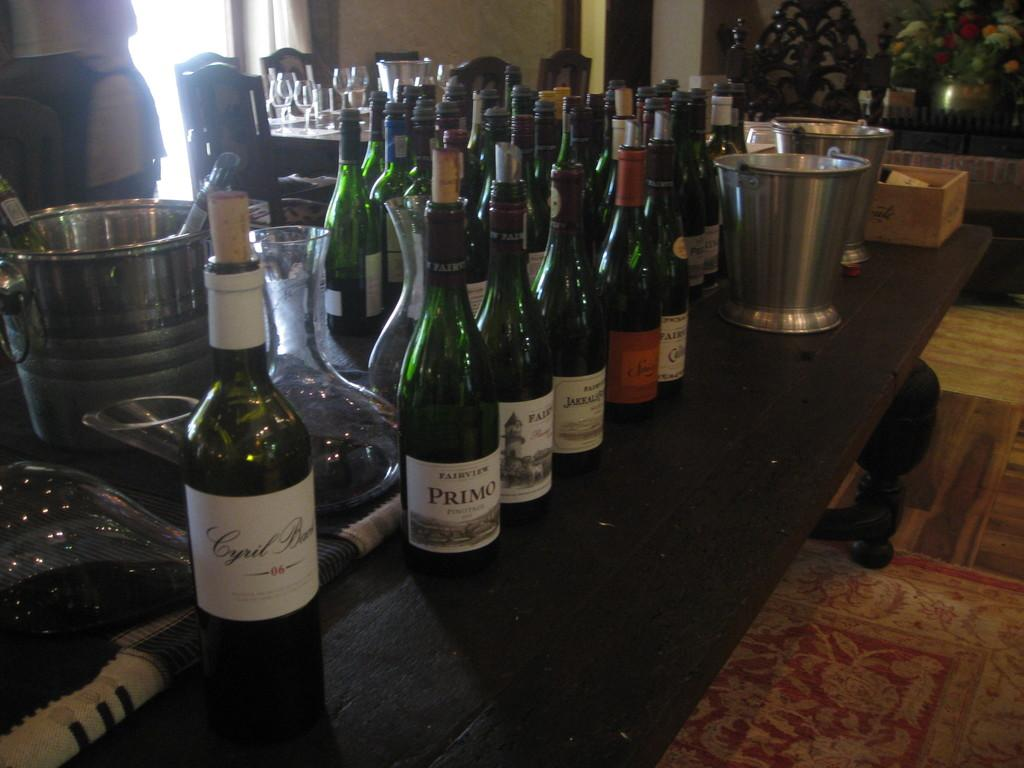<image>
Provide a brief description of the given image. Several bottles are lined up including a bottle of Primo wine. 